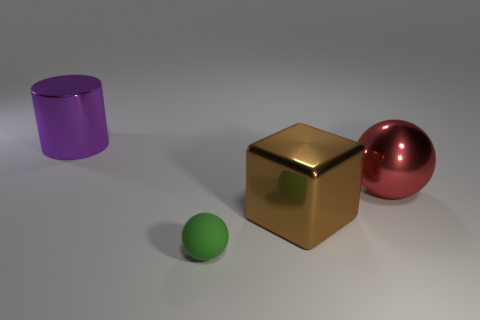There is a small matte sphere; how many big cylinders are left of it?
Provide a succinct answer. 1. Is the large metallic block the same color as the shiny cylinder?
Make the answer very short. No. There is a big purple thing that is made of the same material as the red object; what is its shape?
Keep it short and to the point. Cylinder. There is a big object on the left side of the tiny green thing; is its shape the same as the green rubber thing?
Your response must be concise. No. How many green things are cylinders or rubber things?
Offer a very short reply. 1. Are there the same number of small green rubber objects in front of the rubber object and objects in front of the purple metal cylinder?
Your answer should be compact. No. What is the color of the sphere on the left side of the big shiny thing right of the big shiny object that is in front of the red ball?
Make the answer very short. Green. Are there any other things of the same color as the metal cylinder?
Provide a succinct answer. No. What is the size of the thing that is behind the red metal thing?
Offer a very short reply. Large. What shape is the brown metal object that is the same size as the purple cylinder?
Give a very brief answer. Cube. 